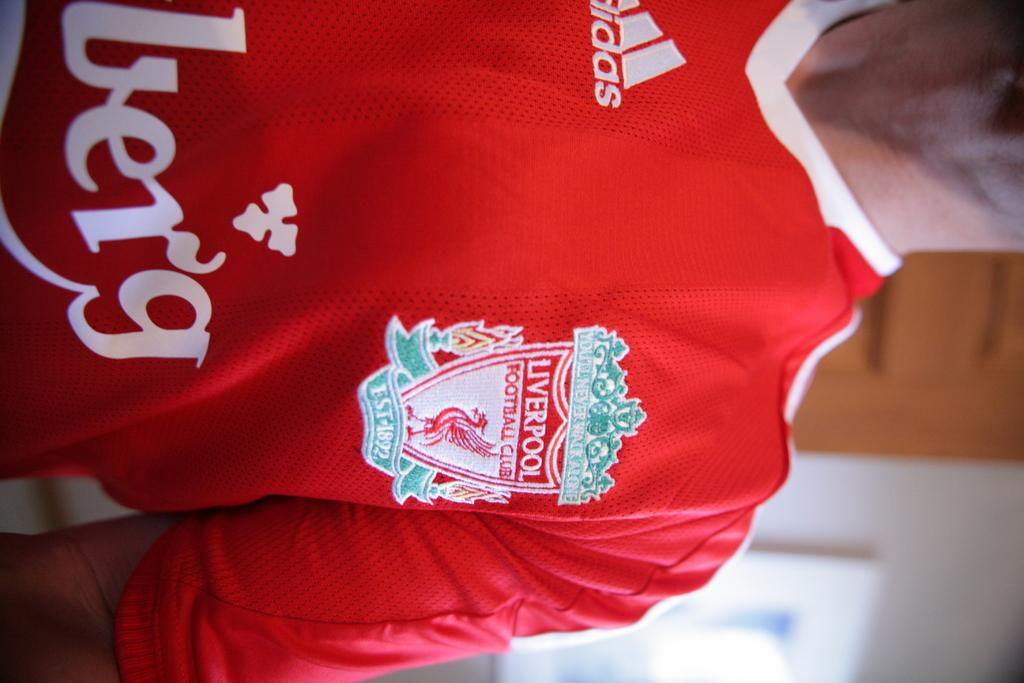Provide a one-sentence caption for the provided image. A person wearing a red liverpool jersey and its a man. 